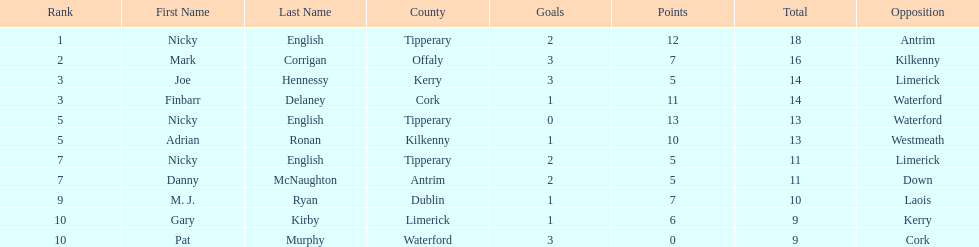Joe hennessy and finbarr delaney both scored how many points? 14. 